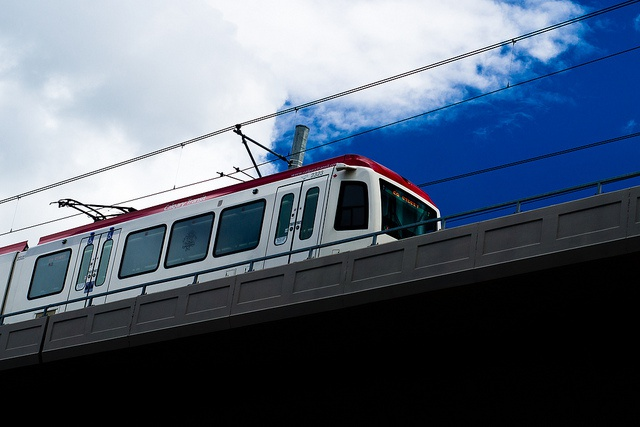Describe the objects in this image and their specific colors. I can see a train in lightblue, darkgray, black, gray, and blue tones in this image. 